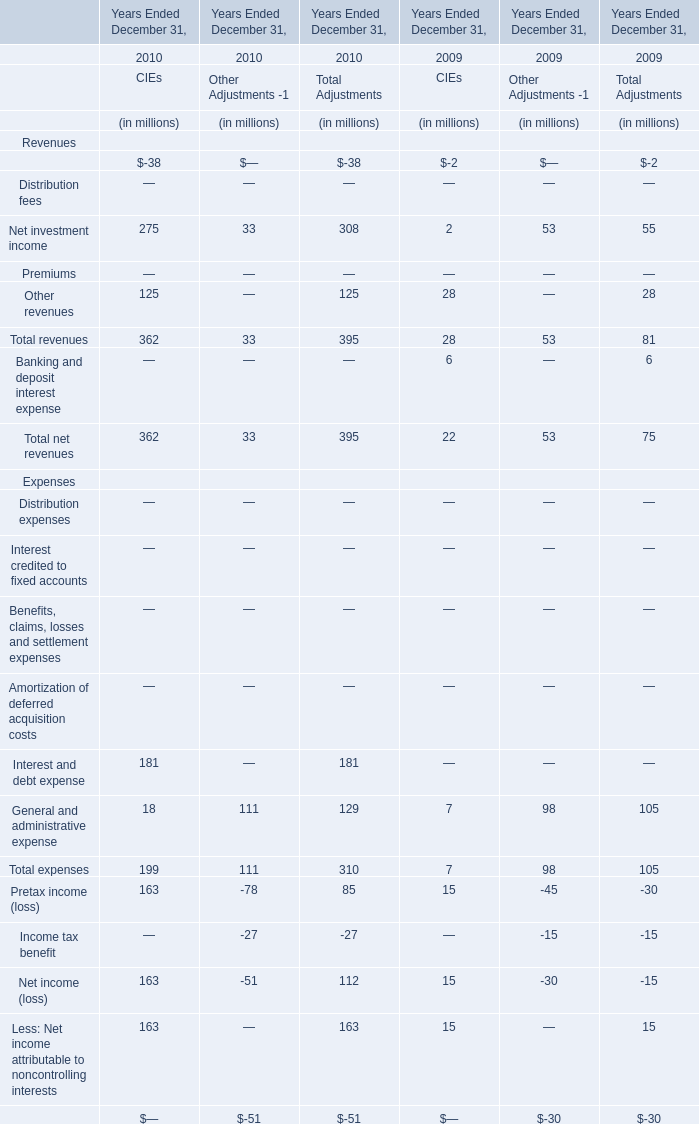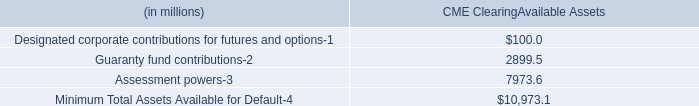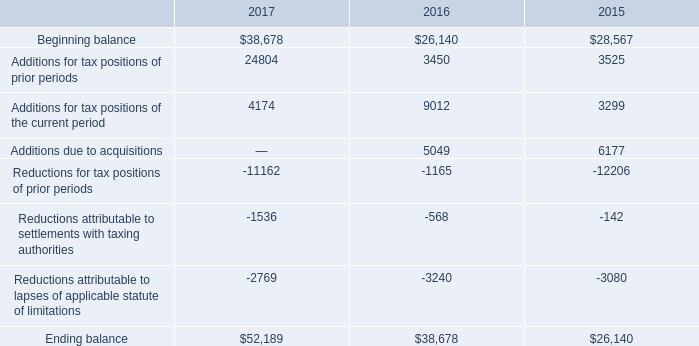What's the average of Beginning balance of 2016, and Guaranty fund contributions of CME ClearingAvailable Assets ? 
Computations: ((26140.0 + 2899.5) / 2)
Answer: 14519.75. what's the total amount of Guaranty fund contributions of CME ClearingAvailable Assets, Beginning balance of 2016, and Additions for tax positions of prior periods of 2016 ? 
Computations: ((2899.5 + 26140.0) + 3450.0)
Answer: 32489.5. 